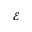Convert formula to latex. <formula><loc_0><loc_0><loc_500><loc_500>\mathcal { E }</formula> 